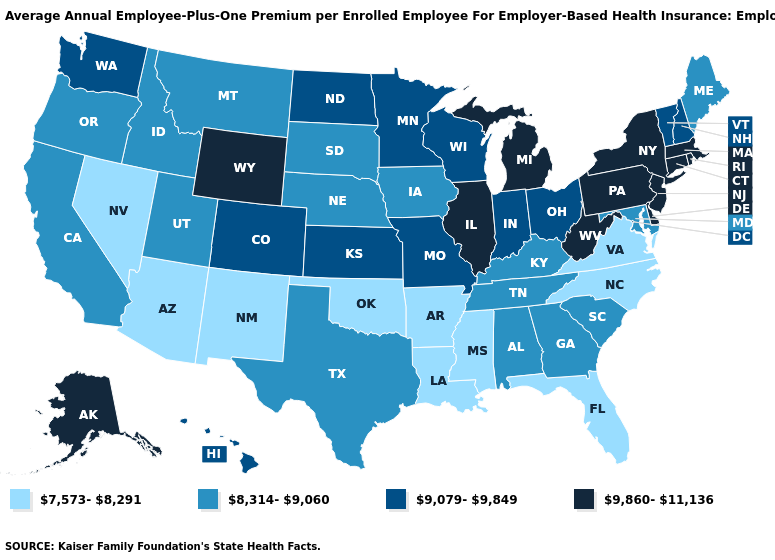What is the value of Illinois?
Keep it brief. 9,860-11,136. Name the states that have a value in the range 9,860-11,136?
Answer briefly. Alaska, Connecticut, Delaware, Illinois, Massachusetts, Michigan, New Jersey, New York, Pennsylvania, Rhode Island, West Virginia, Wyoming. Does New York have the same value as Missouri?
Be succinct. No. Among the states that border Michigan , which have the lowest value?
Quick response, please. Indiana, Ohio, Wisconsin. What is the value of Mississippi?
Short answer required. 7,573-8,291. What is the value of West Virginia?
Be succinct. 9,860-11,136. Does Indiana have the lowest value in the USA?
Answer briefly. No. Does Kansas have the same value as Colorado?
Short answer required. Yes. What is the value of Tennessee?
Keep it brief. 8,314-9,060. What is the value of Connecticut?
Be succinct. 9,860-11,136. Name the states that have a value in the range 7,573-8,291?
Quick response, please. Arizona, Arkansas, Florida, Louisiana, Mississippi, Nevada, New Mexico, North Carolina, Oklahoma, Virginia. What is the highest value in the MidWest ?
Keep it brief. 9,860-11,136. Name the states that have a value in the range 8,314-9,060?
Write a very short answer. Alabama, California, Georgia, Idaho, Iowa, Kentucky, Maine, Maryland, Montana, Nebraska, Oregon, South Carolina, South Dakota, Tennessee, Texas, Utah. Does New Jersey have the highest value in the USA?
Write a very short answer. Yes. Name the states that have a value in the range 8,314-9,060?
Concise answer only. Alabama, California, Georgia, Idaho, Iowa, Kentucky, Maine, Maryland, Montana, Nebraska, Oregon, South Carolina, South Dakota, Tennessee, Texas, Utah. 